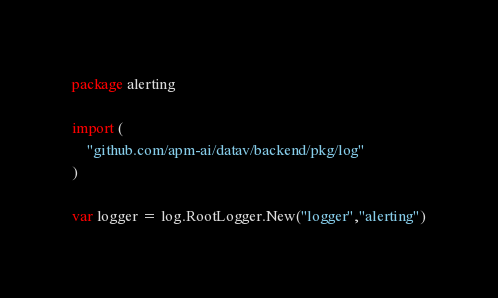Convert code to text. <code><loc_0><loc_0><loc_500><loc_500><_Go_>package alerting

import (
	"github.com/apm-ai/datav/backend/pkg/log"
)

var logger = log.RootLogger.New("logger","alerting")</code> 